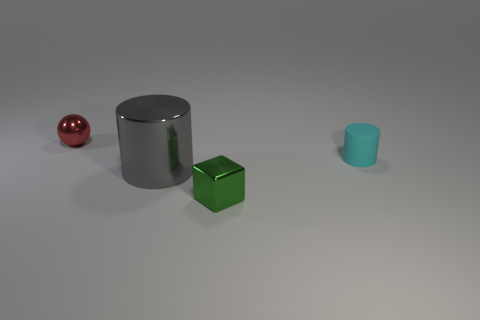There is a small shiny object that is on the right side of the tiny red thing; does it have the same color as the metallic thing that is left of the large shiny cylinder?
Your response must be concise. No. What number of spheres are either gray metallic objects or cyan matte objects?
Give a very brief answer. 0. Are there an equal number of tiny red metallic things right of the small red metallic thing and large gray metallic cylinders?
Offer a terse response. No. There is a cylinder that is to the right of the small metallic object that is right of the gray cylinder that is to the left of the tiny cyan thing; what is its material?
Provide a short and direct response. Rubber. How many things are objects behind the tiny cyan rubber thing or yellow cubes?
Your response must be concise. 1. How many objects are either metallic blocks or small things that are to the left of the large shiny thing?
Ensure brevity in your answer.  2. There is a metal thing in front of the cylinder left of the small cyan cylinder; what number of tiny rubber things are in front of it?
Keep it short and to the point. 0. What is the material of the red ball that is the same size as the cyan cylinder?
Make the answer very short. Metal. Are there any brown metal objects of the same size as the cyan rubber cylinder?
Make the answer very short. No. The sphere is what color?
Your answer should be compact. Red. 